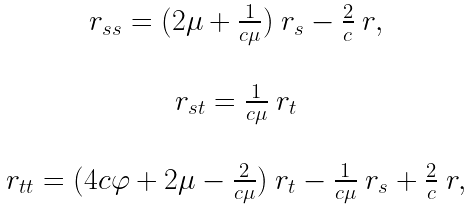Convert formula to latex. <formula><loc_0><loc_0><loc_500><loc_500>\begin{array} { c } { r } _ { s s } = ( 2 \mu + \frac { 1 } { c \mu } ) \ { r } _ { s } - \frac { 2 } { c } \ { r } , \\ \ \\ { r } _ { s t } = \frac { 1 } { c \mu } \ { r } _ { t } \\ \ \\ { r } _ { t t } = ( 4 c \varphi + 2 \mu - \frac { 2 } { c \mu } ) \ { r } _ { t } - \frac { 1 } { c \mu } \ { r } _ { s } + \frac { 2 } { c } \ { r } , \end{array}</formula> 